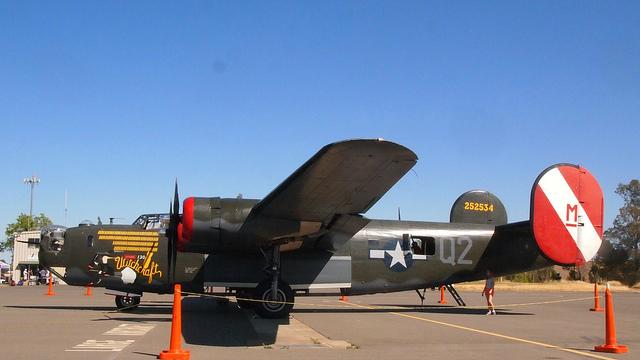Have any of the orange bollards fallen over?
Answer briefly. No. Was this plane built during World War II?
Answer briefly. Yes. What is blue in the photo?
Short answer required. Sky. How many orange cones can be seen?
Be succinct. 7. 